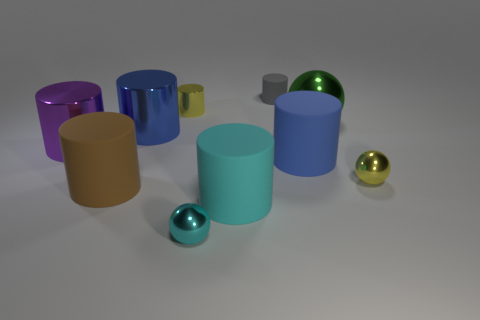The thing that is the same color as the small shiny cylinder is what size?
Provide a succinct answer. Small. There is a object right of the green ball; does it have the same color as the tiny shiny cylinder?
Make the answer very short. Yes. What number of other objects are the same color as the tiny metallic cylinder?
Offer a very short reply. 1. What material is the large purple cylinder?
Your answer should be very brief. Metal. There is a tiny object that is behind the brown matte cylinder and in front of the yellow metal cylinder; what is it made of?
Provide a succinct answer. Metal. What number of things are cylinders that are behind the large purple shiny cylinder or large balls?
Offer a very short reply. 4. Is there a blue metal cylinder of the same size as the purple shiny cylinder?
Ensure brevity in your answer.  Yes. How many matte cylinders are in front of the yellow metallic cylinder and right of the cyan metallic object?
Keep it short and to the point. 2. There is a brown cylinder; how many big blue matte cylinders are in front of it?
Your answer should be compact. 0. Is there another cyan rubber thing that has the same shape as the big cyan thing?
Offer a very short reply. No. 